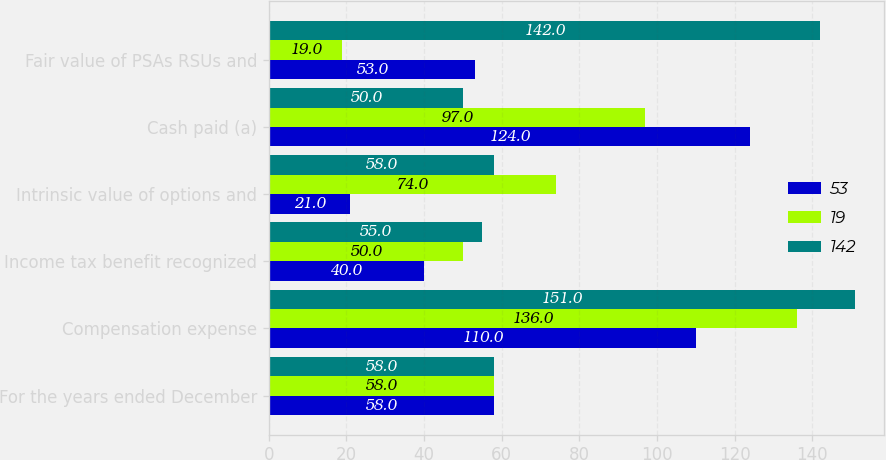Convert chart. <chart><loc_0><loc_0><loc_500><loc_500><stacked_bar_chart><ecel><fcel>For the years ended December<fcel>Compensation expense<fcel>Income tax benefit recognized<fcel>Intrinsic value of options and<fcel>Cash paid (a)<fcel>Fair value of PSAs RSUs and<nl><fcel>53<fcel>58<fcel>110<fcel>40<fcel>21<fcel>124<fcel>53<nl><fcel>19<fcel>58<fcel>136<fcel>50<fcel>74<fcel>97<fcel>19<nl><fcel>142<fcel>58<fcel>151<fcel>55<fcel>58<fcel>50<fcel>142<nl></chart> 